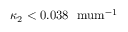<formula> <loc_0><loc_0><loc_500><loc_500>\kappa _ { 2 } < 0 . 0 3 8 \ m u m ^ { - 1 }</formula> 